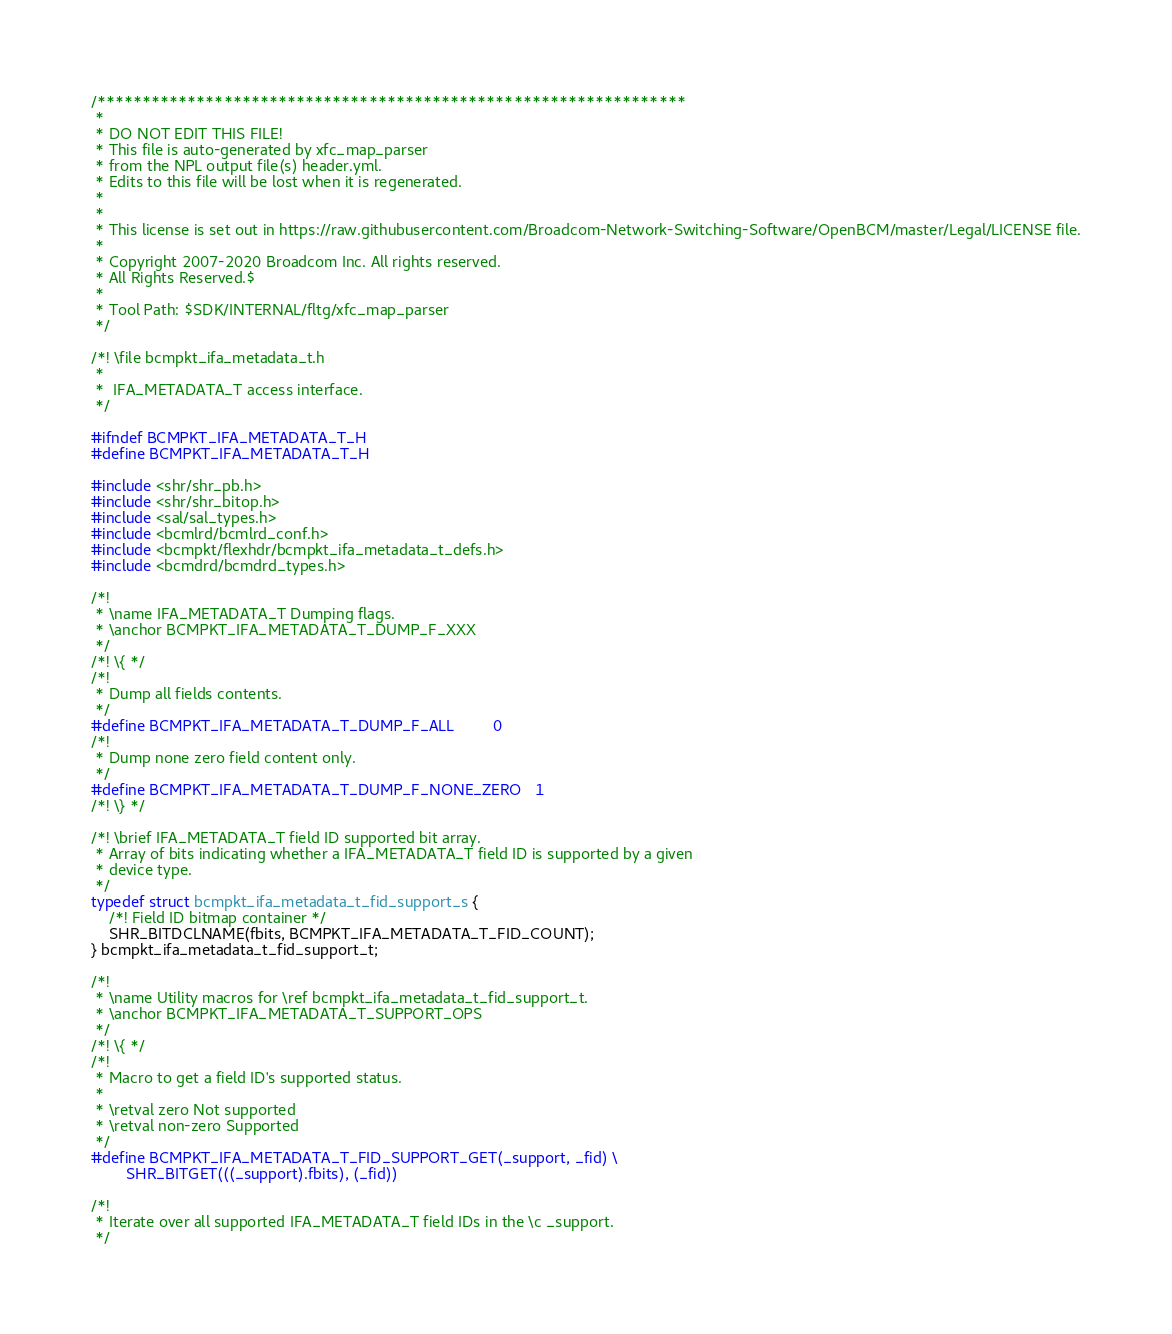Convert code to text. <code><loc_0><loc_0><loc_500><loc_500><_C_>/*****************************************************************
 *
 * DO NOT EDIT THIS FILE!
 * This file is auto-generated by xfc_map_parser
 * from the NPL output file(s) header.yml.
 * Edits to this file will be lost when it is regenerated.
 *
 * 
 * This license is set out in https://raw.githubusercontent.com/Broadcom-Network-Switching-Software/OpenBCM/master/Legal/LICENSE file.
 * 
 * Copyright 2007-2020 Broadcom Inc. All rights reserved.
 * All Rights Reserved.$
 *
 * Tool Path: $SDK/INTERNAL/fltg/xfc_map_parser
 */

/*! \file bcmpkt_ifa_metadata_t.h
 *
 *  IFA_METADATA_T access interface.
 */

#ifndef BCMPKT_IFA_METADATA_T_H
#define BCMPKT_IFA_METADATA_T_H

#include <shr/shr_pb.h>
#include <shr/shr_bitop.h>
#include <sal/sal_types.h>
#include <bcmlrd/bcmlrd_conf.h>
#include <bcmpkt/flexhdr/bcmpkt_ifa_metadata_t_defs.h>
#include <bcmdrd/bcmdrd_types.h>

/*!
 * \name IFA_METADATA_T Dumping flags.
 * \anchor BCMPKT_IFA_METADATA_T_DUMP_F_XXX
 */
/*! \{ */
/*!
 * Dump all fields contents.
 */
#define BCMPKT_IFA_METADATA_T_DUMP_F_ALL         0
/*!
 * Dump none zero field content only.
 */
#define BCMPKT_IFA_METADATA_T_DUMP_F_NONE_ZERO   1
/*! \} */

/*! \brief IFA_METADATA_T field ID supported bit array.
 * Array of bits indicating whether a IFA_METADATA_T field ID is supported by a given
 * device type.
 */
typedef struct bcmpkt_ifa_metadata_t_fid_support_s {
    /*! Field ID bitmap container */
    SHR_BITDCLNAME(fbits, BCMPKT_IFA_METADATA_T_FID_COUNT);
} bcmpkt_ifa_metadata_t_fid_support_t;

/*!
 * \name Utility macros for \ref bcmpkt_ifa_metadata_t_fid_support_t.
 * \anchor BCMPKT_IFA_METADATA_T_SUPPORT_OPS
 */
/*! \{ */
/*!
 * Macro to get a field ID's supported status.
 *
 * \retval zero Not supported
 * \retval non-zero Supported
 */
#define BCMPKT_IFA_METADATA_T_FID_SUPPORT_GET(_support, _fid) \
        SHR_BITGET(((_support).fbits), (_fid))

/*!
 * Iterate over all supported IFA_METADATA_T field IDs in the \c _support.
 */</code> 